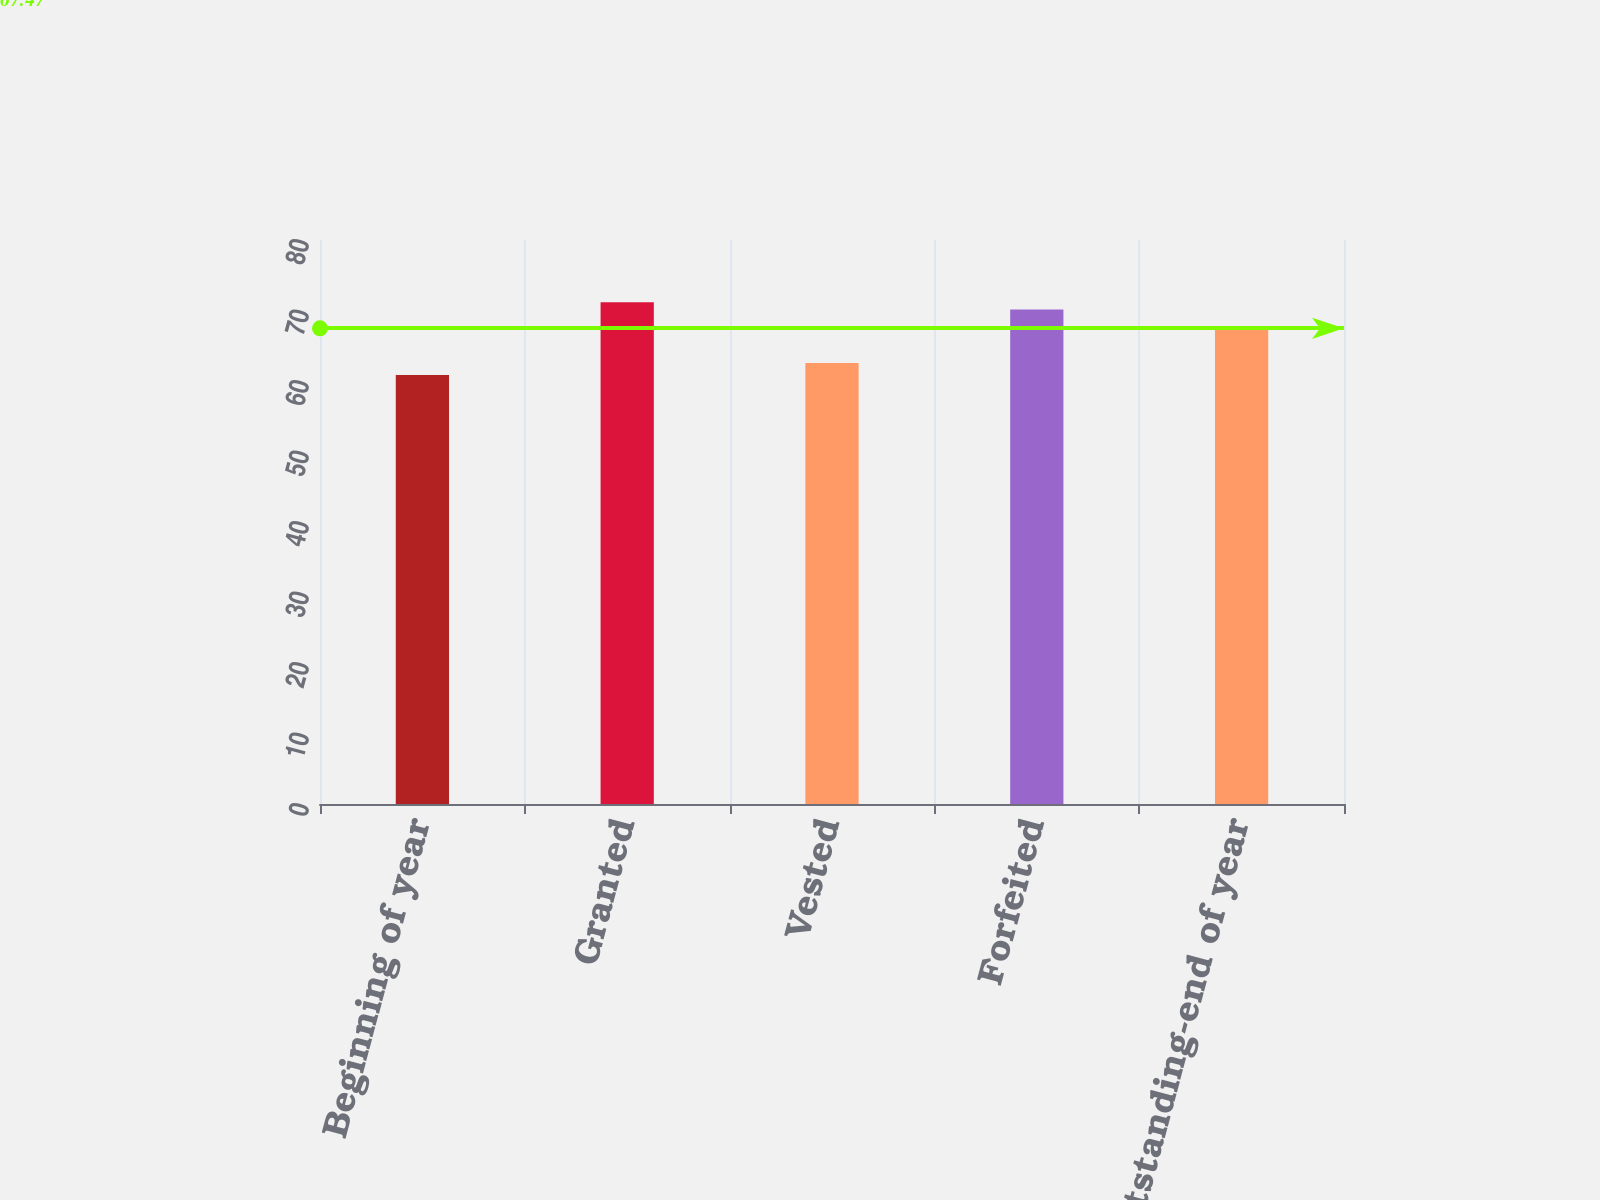<chart> <loc_0><loc_0><loc_500><loc_500><bar_chart><fcel>Beginning of year<fcel>Granted<fcel>Vested<fcel>Forfeited<fcel>Outstanding-end of year<nl><fcel>60.86<fcel>71.17<fcel>62.57<fcel>70.14<fcel>67.6<nl></chart> 